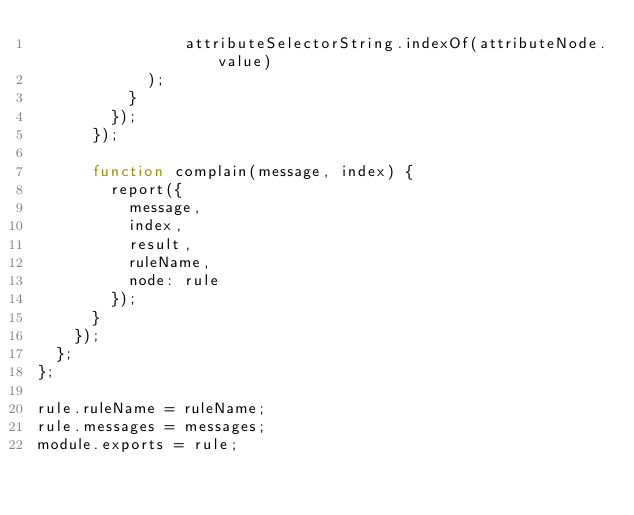<code> <loc_0><loc_0><loc_500><loc_500><_JavaScript_>                attributeSelectorString.indexOf(attributeNode.value)
            );
          }
        });
      });

      function complain(message, index) {
        report({
          message,
          index,
          result,
          ruleName,
          node: rule
        });
      }
    });
  };
};

rule.ruleName = ruleName;
rule.messages = messages;
module.exports = rule;
</code> 